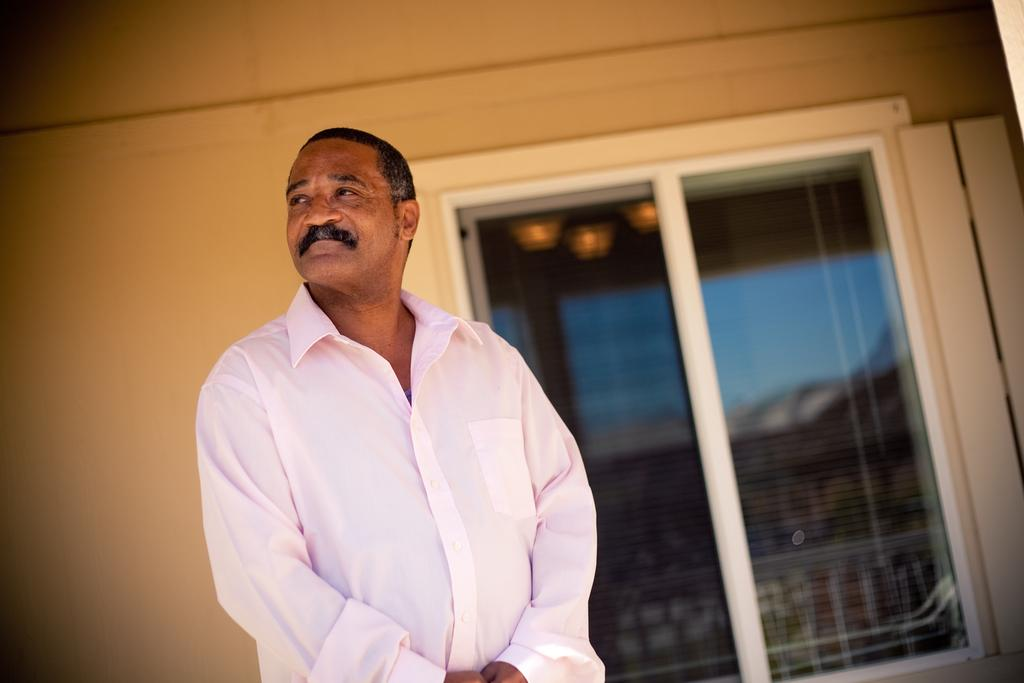Who is present in the image? There is a man in the image. Where is the man positioned in the image? The man is positioned towards the left side of the image. What is the man wearing in the image? The man is wearing a pink shirt in the image. What can be seen in the background of the image? There is a wall in the background of the image, and a window is present in the wall. How many beggars are visible in the image? There are no beggars present in the image; it features a man wearing a pink shirt. What type of rat can be seen interacting with the man in the image? There is no rat present in the image; the man is the only person visible. 